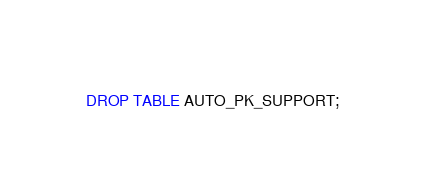Convert code to text. <code><loc_0><loc_0><loc_500><loc_500><_SQL_>DROP TABLE AUTO_PK_SUPPORT;
</code> 